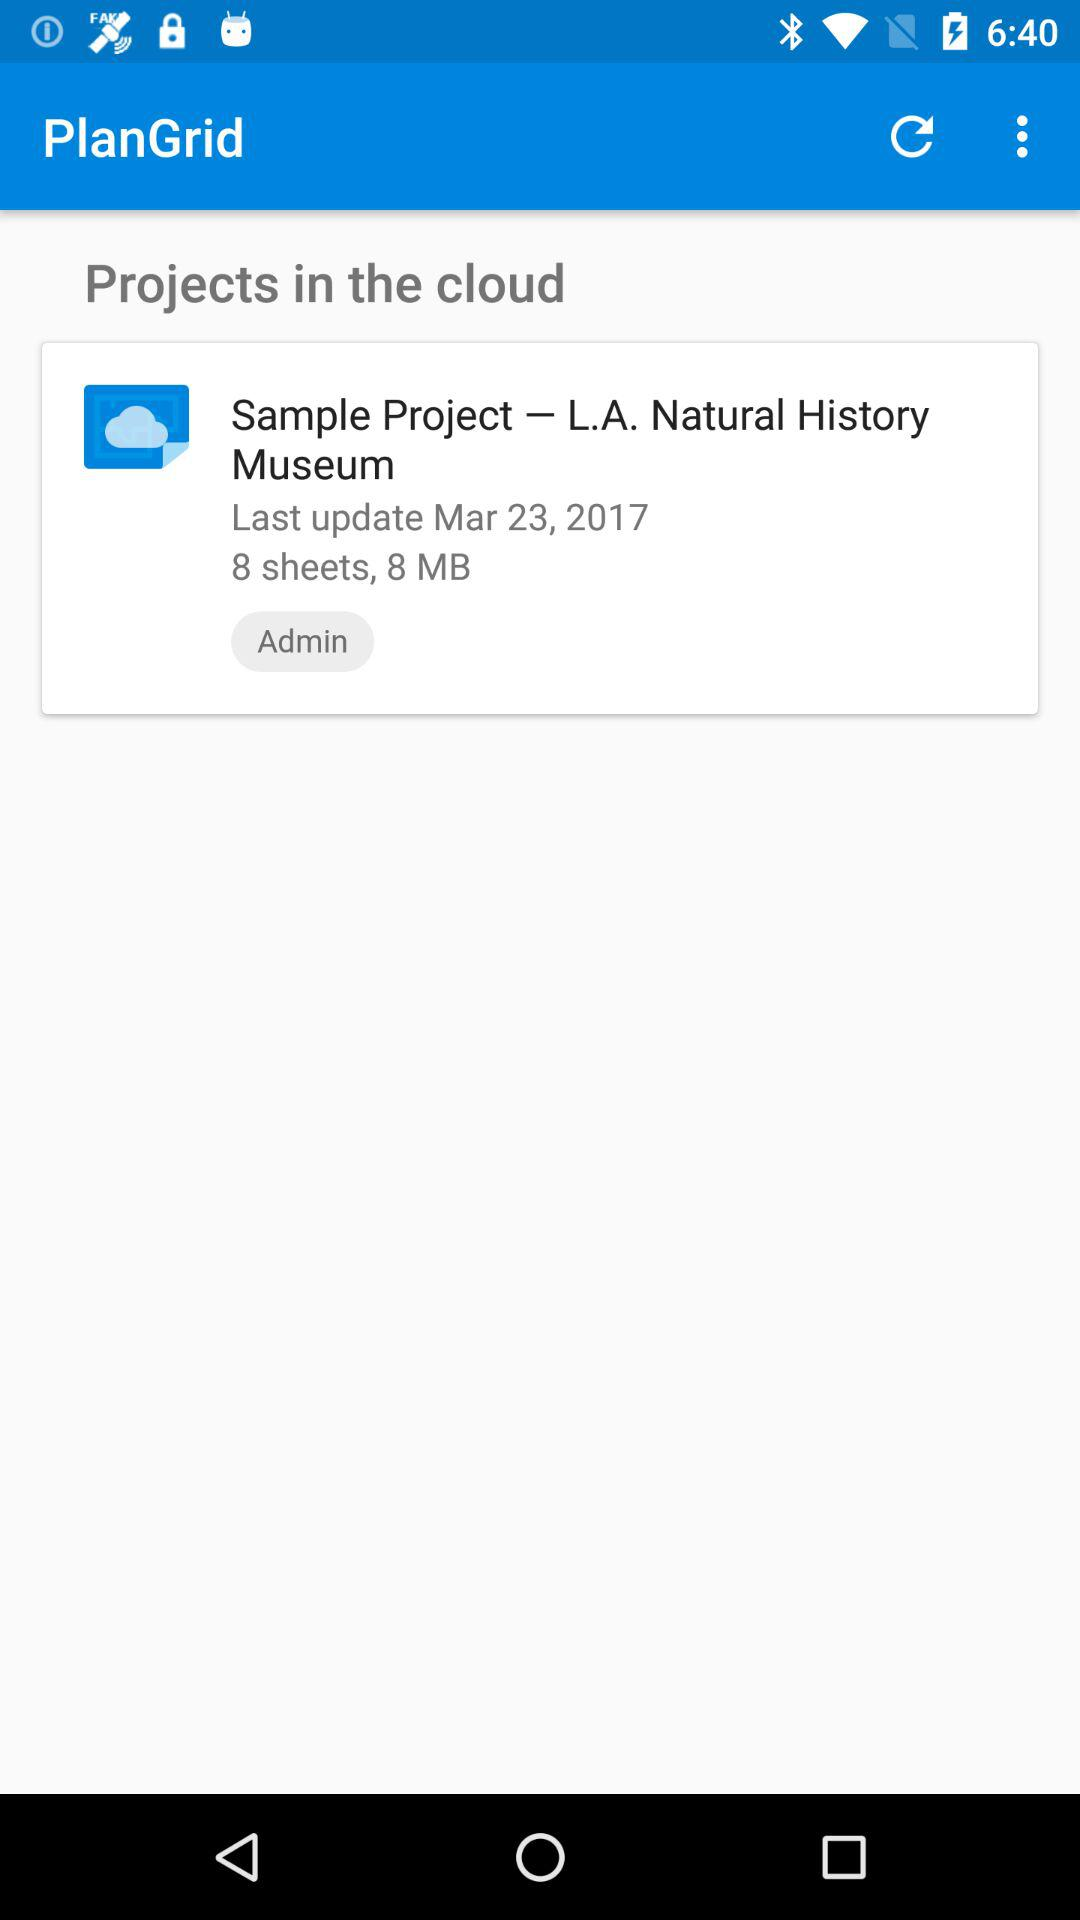How many MB are there? There are 8 MB. 